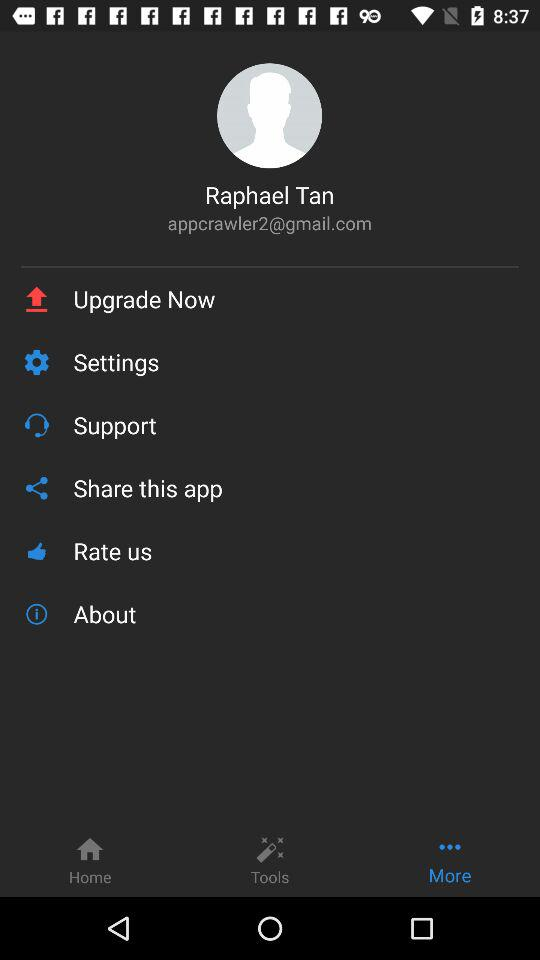What Gmail address is used? The used Gmail address is appcrawler2@gmail.com. 